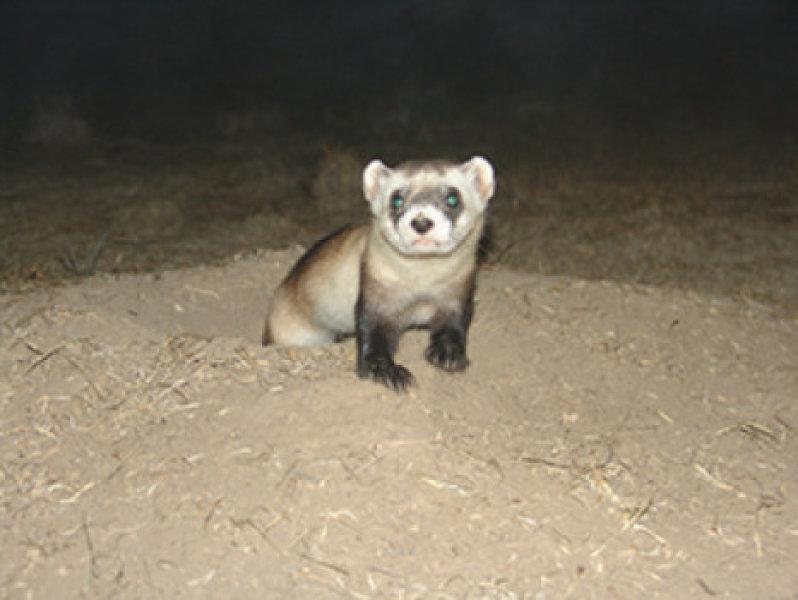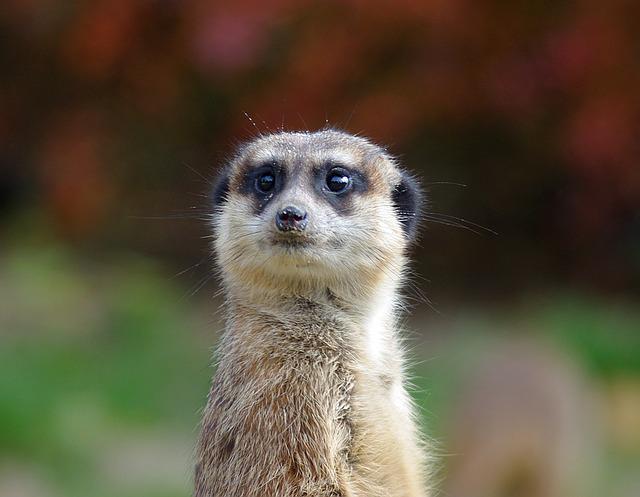The first image is the image on the left, the second image is the image on the right. Given the left and right images, does the statement "There is an animal that is not a ferret." hold true? Answer yes or no. Yes. The first image is the image on the left, the second image is the image on the right. Evaluate the accuracy of this statement regarding the images: "There is one animal photographed in front of a white background.". Is it true? Answer yes or no. No. 